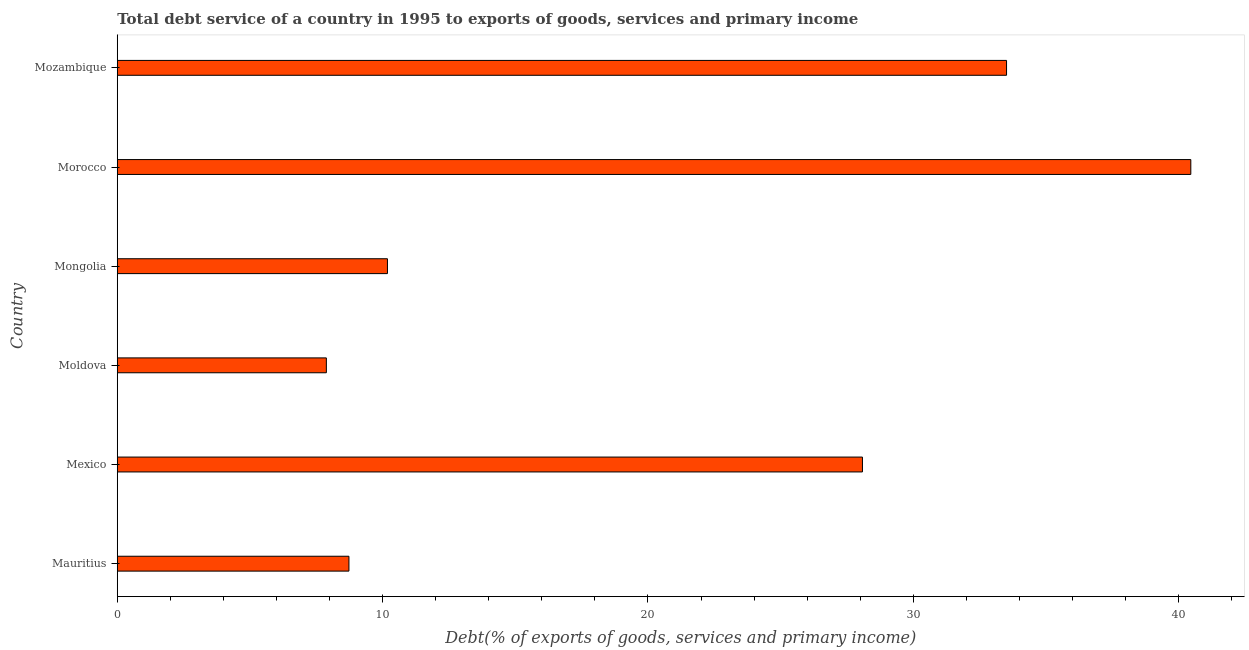Does the graph contain any zero values?
Your response must be concise. No. Does the graph contain grids?
Offer a very short reply. No. What is the title of the graph?
Ensure brevity in your answer.  Total debt service of a country in 1995 to exports of goods, services and primary income. What is the label or title of the X-axis?
Offer a very short reply. Debt(% of exports of goods, services and primary income). What is the label or title of the Y-axis?
Provide a succinct answer. Country. What is the total debt service in Mozambique?
Provide a short and direct response. 33.51. Across all countries, what is the maximum total debt service?
Your answer should be compact. 40.46. Across all countries, what is the minimum total debt service?
Provide a short and direct response. 7.88. In which country was the total debt service maximum?
Provide a succinct answer. Morocco. In which country was the total debt service minimum?
Make the answer very short. Moldova. What is the sum of the total debt service?
Offer a very short reply. 128.85. What is the difference between the total debt service in Mongolia and Mozambique?
Ensure brevity in your answer.  -23.33. What is the average total debt service per country?
Your answer should be very brief. 21.48. What is the median total debt service?
Offer a very short reply. 19.13. In how many countries, is the total debt service greater than 34 %?
Offer a very short reply. 1. What is the ratio of the total debt service in Moldova to that in Mongolia?
Keep it short and to the point. 0.77. What is the difference between the highest and the second highest total debt service?
Your response must be concise. 6.94. Is the sum of the total debt service in Morocco and Mozambique greater than the maximum total debt service across all countries?
Give a very brief answer. Yes. What is the difference between the highest and the lowest total debt service?
Give a very brief answer. 32.58. In how many countries, is the total debt service greater than the average total debt service taken over all countries?
Keep it short and to the point. 3. Are all the bars in the graph horizontal?
Ensure brevity in your answer.  Yes. How many countries are there in the graph?
Make the answer very short. 6. Are the values on the major ticks of X-axis written in scientific E-notation?
Provide a succinct answer. No. What is the Debt(% of exports of goods, services and primary income) of Mauritius?
Make the answer very short. 8.73. What is the Debt(% of exports of goods, services and primary income) in Mexico?
Offer a very short reply. 28.08. What is the Debt(% of exports of goods, services and primary income) of Moldova?
Your answer should be very brief. 7.88. What is the Debt(% of exports of goods, services and primary income) of Mongolia?
Ensure brevity in your answer.  10.18. What is the Debt(% of exports of goods, services and primary income) in Morocco?
Your answer should be very brief. 40.46. What is the Debt(% of exports of goods, services and primary income) of Mozambique?
Make the answer very short. 33.51. What is the difference between the Debt(% of exports of goods, services and primary income) in Mauritius and Mexico?
Provide a succinct answer. -19.35. What is the difference between the Debt(% of exports of goods, services and primary income) in Mauritius and Moldova?
Ensure brevity in your answer.  0.85. What is the difference between the Debt(% of exports of goods, services and primary income) in Mauritius and Mongolia?
Provide a succinct answer. -1.45. What is the difference between the Debt(% of exports of goods, services and primary income) in Mauritius and Morocco?
Offer a terse response. -31.73. What is the difference between the Debt(% of exports of goods, services and primary income) in Mauritius and Mozambique?
Provide a short and direct response. -24.78. What is the difference between the Debt(% of exports of goods, services and primary income) in Mexico and Moldova?
Make the answer very short. 20.2. What is the difference between the Debt(% of exports of goods, services and primary income) in Mexico and Mongolia?
Offer a terse response. 17.9. What is the difference between the Debt(% of exports of goods, services and primary income) in Mexico and Morocco?
Keep it short and to the point. -12.38. What is the difference between the Debt(% of exports of goods, services and primary income) in Mexico and Mozambique?
Offer a very short reply. -5.43. What is the difference between the Debt(% of exports of goods, services and primary income) in Moldova and Mongolia?
Provide a succinct answer. -2.3. What is the difference between the Debt(% of exports of goods, services and primary income) in Moldova and Morocco?
Your answer should be very brief. -32.58. What is the difference between the Debt(% of exports of goods, services and primary income) in Moldova and Mozambique?
Your answer should be compact. -25.63. What is the difference between the Debt(% of exports of goods, services and primary income) in Mongolia and Morocco?
Offer a terse response. -30.28. What is the difference between the Debt(% of exports of goods, services and primary income) in Mongolia and Mozambique?
Provide a short and direct response. -23.33. What is the difference between the Debt(% of exports of goods, services and primary income) in Morocco and Mozambique?
Offer a very short reply. 6.94. What is the ratio of the Debt(% of exports of goods, services and primary income) in Mauritius to that in Mexico?
Your answer should be very brief. 0.31. What is the ratio of the Debt(% of exports of goods, services and primary income) in Mauritius to that in Moldova?
Ensure brevity in your answer.  1.11. What is the ratio of the Debt(% of exports of goods, services and primary income) in Mauritius to that in Mongolia?
Provide a succinct answer. 0.86. What is the ratio of the Debt(% of exports of goods, services and primary income) in Mauritius to that in Morocco?
Your answer should be very brief. 0.22. What is the ratio of the Debt(% of exports of goods, services and primary income) in Mauritius to that in Mozambique?
Make the answer very short. 0.26. What is the ratio of the Debt(% of exports of goods, services and primary income) in Mexico to that in Moldova?
Provide a short and direct response. 3.56. What is the ratio of the Debt(% of exports of goods, services and primary income) in Mexico to that in Mongolia?
Keep it short and to the point. 2.76. What is the ratio of the Debt(% of exports of goods, services and primary income) in Mexico to that in Morocco?
Your answer should be compact. 0.69. What is the ratio of the Debt(% of exports of goods, services and primary income) in Mexico to that in Mozambique?
Your response must be concise. 0.84. What is the ratio of the Debt(% of exports of goods, services and primary income) in Moldova to that in Mongolia?
Your response must be concise. 0.77. What is the ratio of the Debt(% of exports of goods, services and primary income) in Moldova to that in Morocco?
Your answer should be compact. 0.2. What is the ratio of the Debt(% of exports of goods, services and primary income) in Moldova to that in Mozambique?
Your answer should be compact. 0.23. What is the ratio of the Debt(% of exports of goods, services and primary income) in Mongolia to that in Morocco?
Provide a succinct answer. 0.25. What is the ratio of the Debt(% of exports of goods, services and primary income) in Mongolia to that in Mozambique?
Your answer should be very brief. 0.3. What is the ratio of the Debt(% of exports of goods, services and primary income) in Morocco to that in Mozambique?
Make the answer very short. 1.21. 